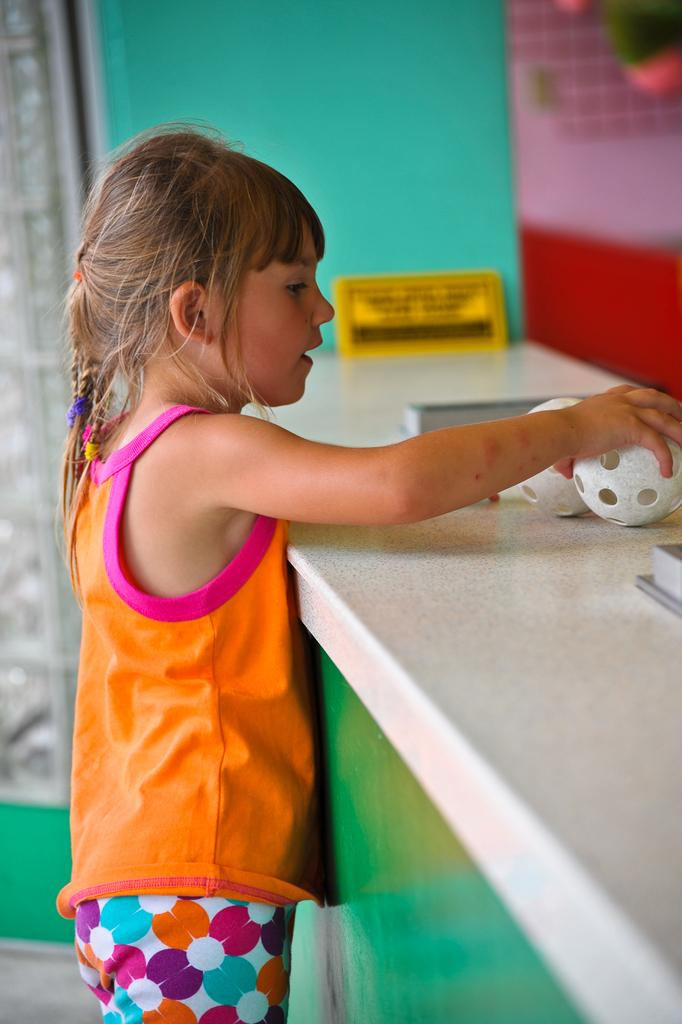Who is the main subject in the picture? There is a girl in the picture. What is the girl holding in the image? The girl is holding a ball. Where is the ball located in the image? The ball is on a countertop. What other text-related object can be seen in the image? There is a small board with text in the image. How many balls are visible in the image? There are two balls visible in the image. What type of quince is being used as a chair in the image? There is no quince or chair present in the image. How many girls are visible in the image? There is only one girl visible in the image. 